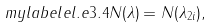<formula> <loc_0><loc_0><loc_500><loc_500>\ m y l a b e l { e l . e 3 . 4 } N ( \lambda ) = N ( \lambda _ { 2 i } ) ,</formula> 